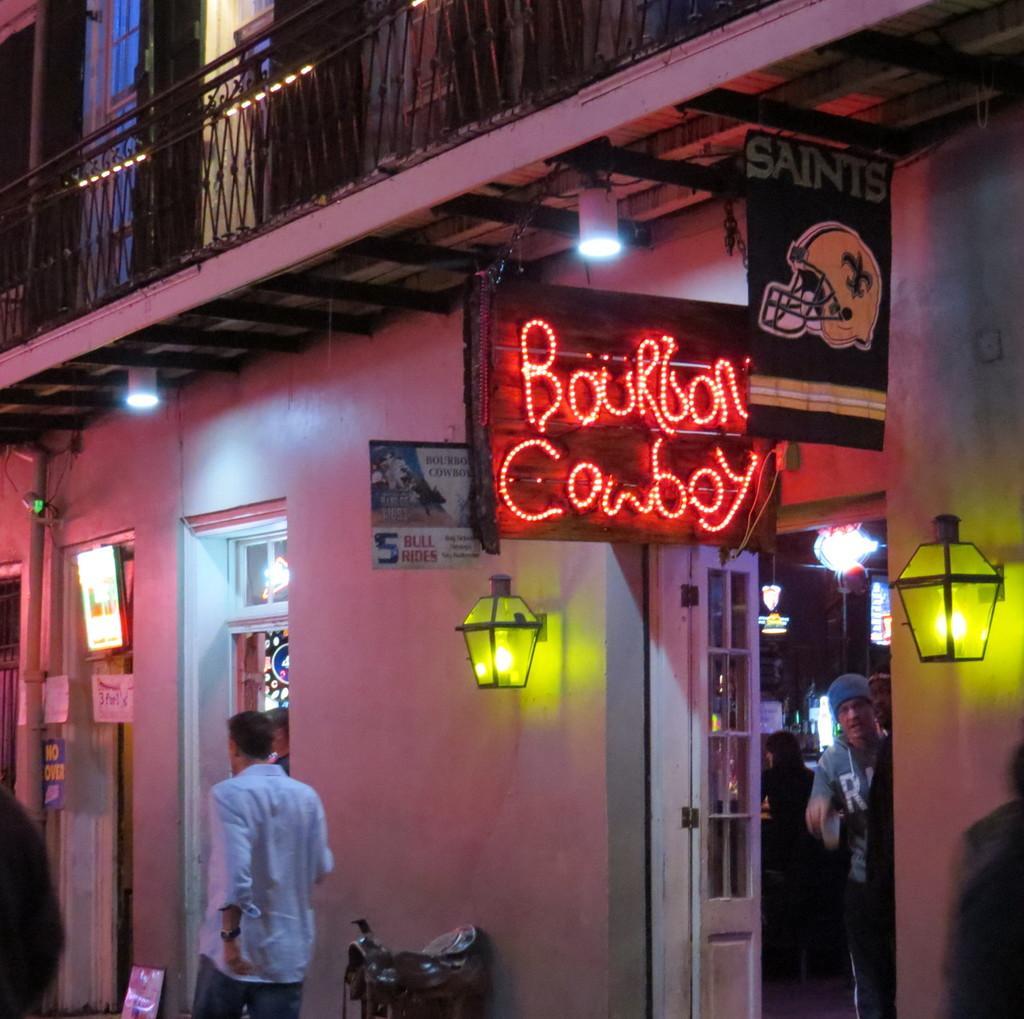Could you give a brief overview of what you see in this image? In this picture I can see the building. In the bottom right I can see some people who are standing inside the room. Beside them I can see the door. In the bottom left there is a man who is wearing shirt, watch and jeans. He is standing near to the chairs. Beside the door I can see the board and lights. At the top I can see the railing. 